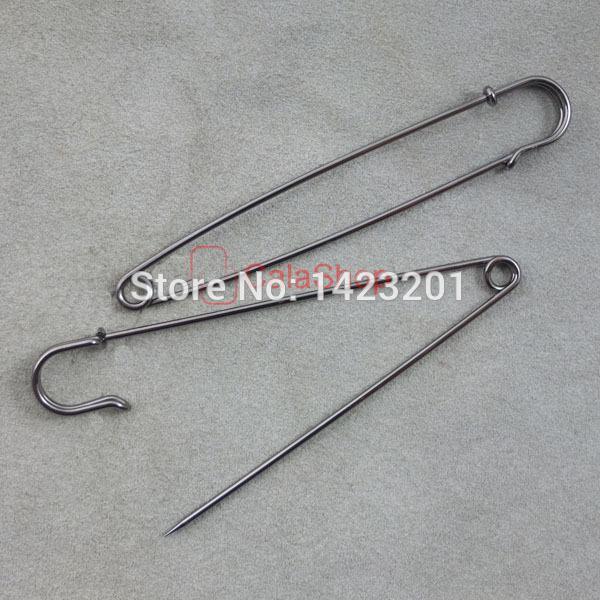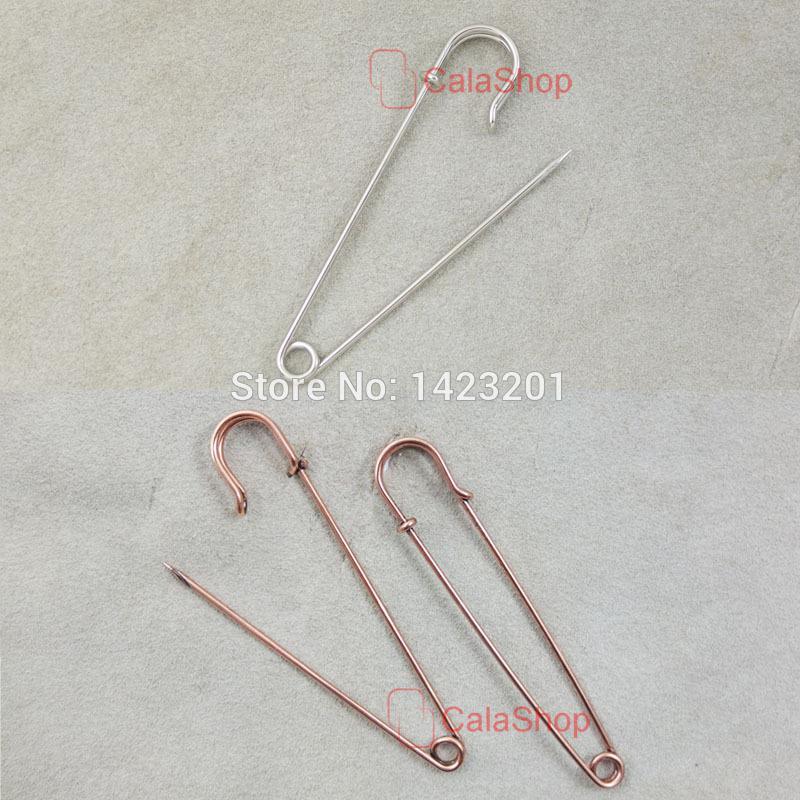The first image is the image on the left, the second image is the image on the right. Analyze the images presented: Is the assertion "One image contains exactly two safety pins." valid? Answer yes or no. Yes. 